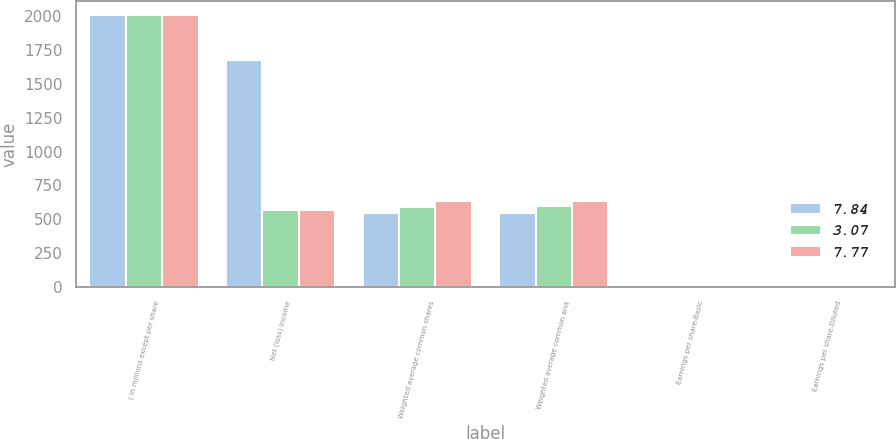Convert chart to OTSL. <chart><loc_0><loc_0><loc_500><loc_500><stacked_bar_chart><ecel><fcel>( in millions except per share<fcel>Net (loss) income<fcel>Weighted average common shares<fcel>Weighted average common and<fcel>Earnings per share-Basic<fcel>Earnings per share-Diluted<nl><fcel>7.84<fcel>2008<fcel>1679<fcel>546.1<fcel>546.1<fcel>3.07<fcel>3.07<nl><fcel>3.07<fcel>2007<fcel>569.25<fcel>592.4<fcel>596.7<fcel>7.83<fcel>7.77<nl><fcel>7.77<fcel>2006<fcel>569.25<fcel>632.5<fcel>637.2<fcel>7.89<fcel>7.84<nl></chart> 